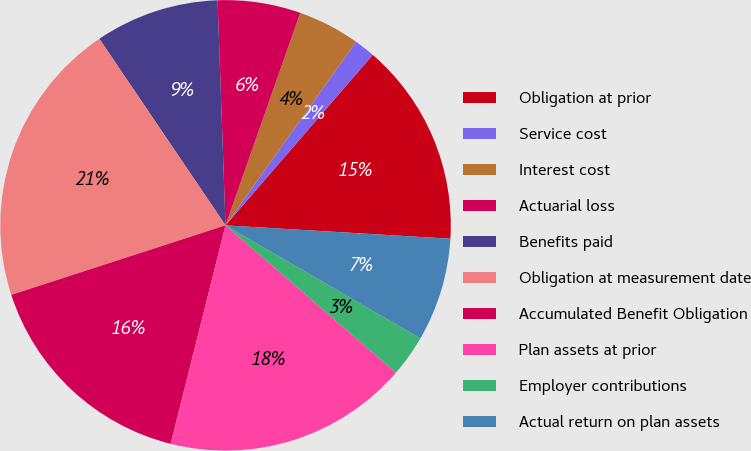Convert chart to OTSL. <chart><loc_0><loc_0><loc_500><loc_500><pie_chart><fcel>Obligation at prior<fcel>Service cost<fcel>Interest cost<fcel>Actuarial loss<fcel>Benefits paid<fcel>Obligation at measurement date<fcel>Accumulated Benefit Obligation<fcel>Plan assets at prior<fcel>Employer contributions<fcel>Actual return on plan assets<nl><fcel>14.61%<fcel>1.5%<fcel>4.46%<fcel>5.94%<fcel>8.9%<fcel>20.53%<fcel>16.09%<fcel>17.57%<fcel>2.98%<fcel>7.42%<nl></chart> 